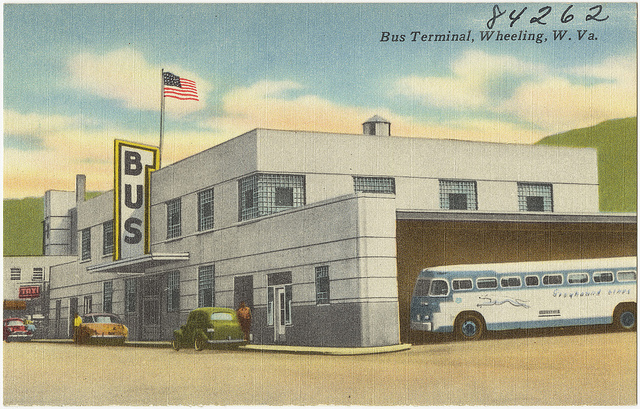<image>Where is the truck parked? I don't know where the truck is parked as it is not seen in the image. However, it can be beside a building or at a bus stop. What does it say after street scene? I am not sure. It can say 'bus' or 'wheeling w va' after street scene. What does it say after street scene? I am not sure what it says after street scene. It can be either 'bus' or 'wheeling w va'. Where is the truck parked? I don't know where the truck is parked. It can be parked beside the building or by the building. 